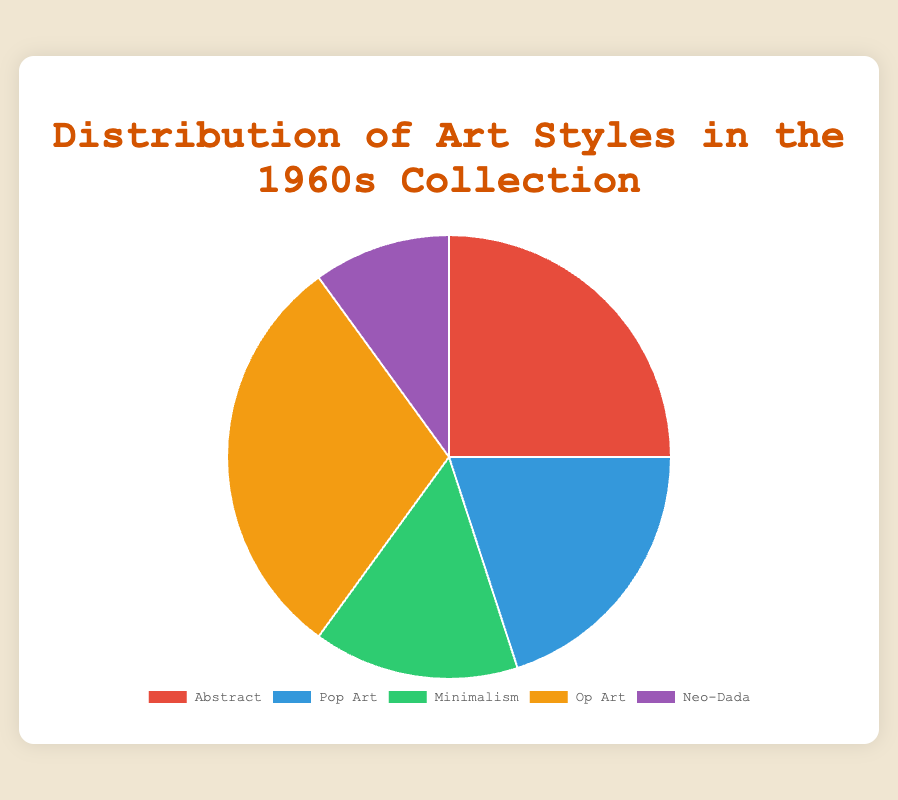What percentage of the 1960s collection does Minimalism represent? Minimalism is represented by a percentage slice in the pie chart. According to the data, Minimalism accounts for 15%.
Answer: 15% Which art style occupies the largest portion of the collection? The largest portion of the pie chart is represented by the slice with the highest percentage. According to the data, Op Art has the highest percentage at 30%.
Answer: Op Art How much larger is the Abstract portion compared to Neo-Dada? To find the difference between Abstract and Neo-Dada, subtract the percentage of Neo-Dada from Abstract (25% - 10% = 15%). Hence, Abstract is 15% larger than Neo-Dada.
Answer: 15% What is the combined percentage of Abstract and Pop Art? Add the percentages of Abstract and Pop Art to find their combined percentage (25% + 20% = 45%).
Answer: 45% Which art style has a smaller representation than Minimalism but larger than Neo-Dada? First, identify the percentages: Minimalism is 15%, and Neo-Dada is 10%. The style with a percentage between these values is Pop Art, which is 20%. However, Pop Art is larger than Minimalism, so the styles fitting the criteria are none.
Answer: None What is the average percentage representation of all the art styles in the data? Add the percentages of all art styles and divide by the number of styles (25% + 20% + 15% + 30% + 10% = 100%, then 100% / 5 = 20%).
Answer: 20% Which art styles are represented by the least amount and what is the percentage? The smallest portion in the pie chart is represented by Neo-Dada, which has the lowest percentage at 10%.
Answer: Neo-Dada, 10% By how much does Op Art exceed the percentages of both Minimalism and Neo-Dada combined? First, find the total percentage of Minimalism and Neo-Dada (15% + 10% = 25%). Then, subtract this combined percentage from Op Art's percentage (30% - 25% = 5%).
Answer: 5% If you combine the three least represented art styles, what percentage of the collection do they form? Add the percentages of Pop Art, Minimalism, and Neo-Dada (20% + 15% + 10% = 45%).
Answer: 45% 